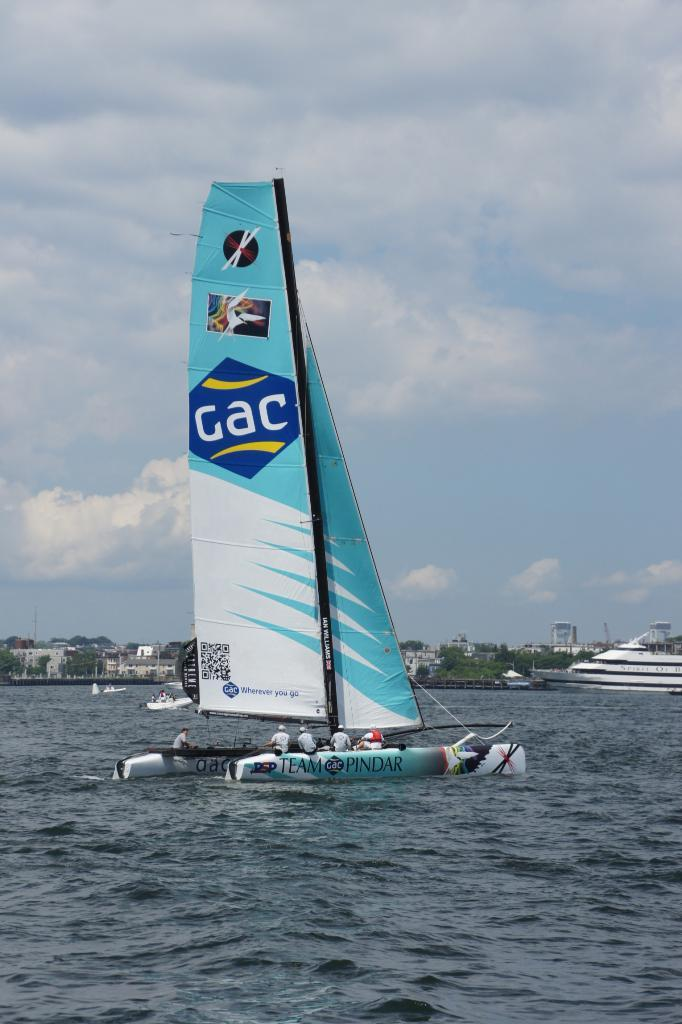What are the people in the image doing? The people in the image are sitting in ships. Where are the ships located in the image? The ships are on the water surface. What can be seen in the background of the image? There are buildings visible in the image. What type of vegetation is present in the image? Trees are present in the image. What is visible above the ships and trees in the image? The sky is visible in the image. What type of question is being asked in the image? There is no question being asked in the image; it features people sitting in ships on the water surface. 